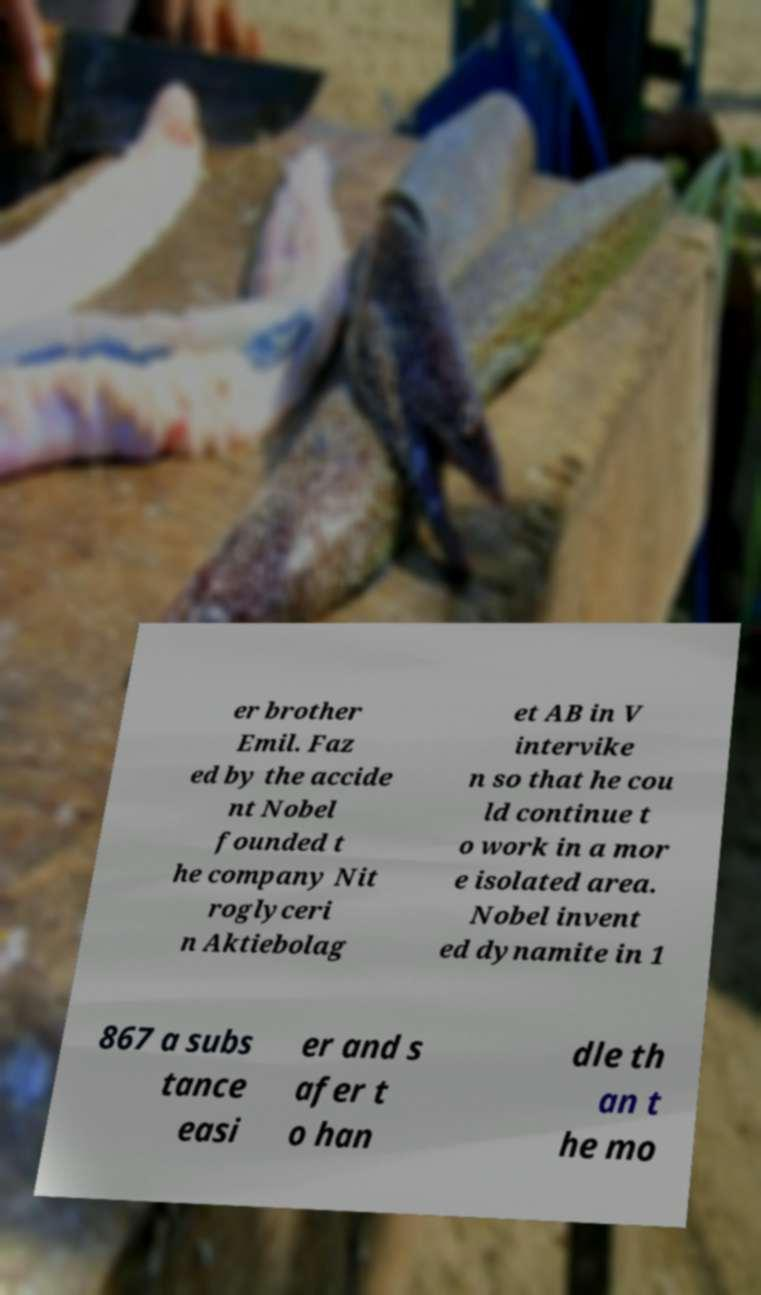Can you read and provide the text displayed in the image?This photo seems to have some interesting text. Can you extract and type it out for me? er brother Emil. Faz ed by the accide nt Nobel founded t he company Nit roglyceri n Aktiebolag et AB in V intervike n so that he cou ld continue t o work in a mor e isolated area. Nobel invent ed dynamite in 1 867 a subs tance easi er and s afer t o han dle th an t he mo 